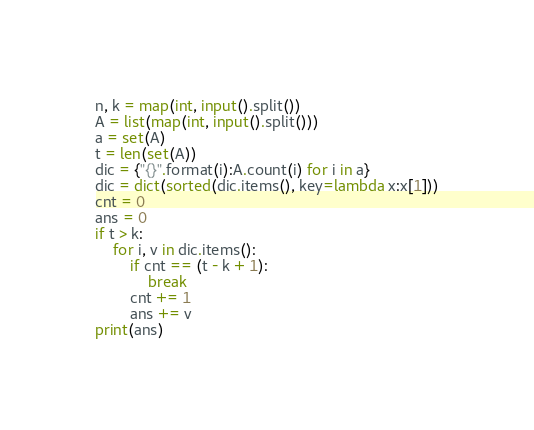Convert code to text. <code><loc_0><loc_0><loc_500><loc_500><_Python_>n, k = map(int, input().split())
A = list(map(int, input().split()))
a = set(A)
t = len(set(A))
dic = {"{}".format(i):A.count(i) for i in a}
dic = dict(sorted(dic.items(), key=lambda x:x[1]))
cnt = 0
ans = 0
if t > k:
    for i, v in dic.items():
        if cnt == (t - k + 1):
            break
        cnt += 1
        ans += v
print(ans)
</code> 